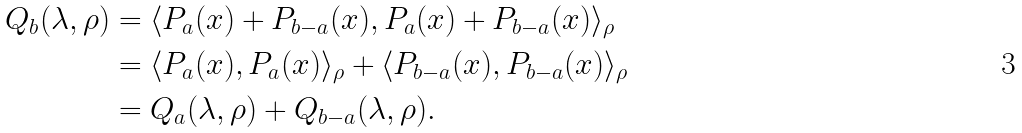Convert formula to latex. <formula><loc_0><loc_0><loc_500><loc_500>Q _ { b } ( \lambda , \rho ) & = \langle P _ { a } ( x ) + P _ { b - a } ( x ) , P _ { a } ( x ) + P _ { b - a } ( x ) \rangle _ { \rho } \\ & = \langle P _ { a } ( x ) , P _ { a } ( x ) \rangle _ { \rho } + \langle P _ { b - a } ( x ) , P _ { b - a } ( x ) \rangle _ { \rho } \\ & = Q _ { a } ( \lambda , \rho ) + Q _ { b - a } ( \lambda , \rho ) .</formula> 